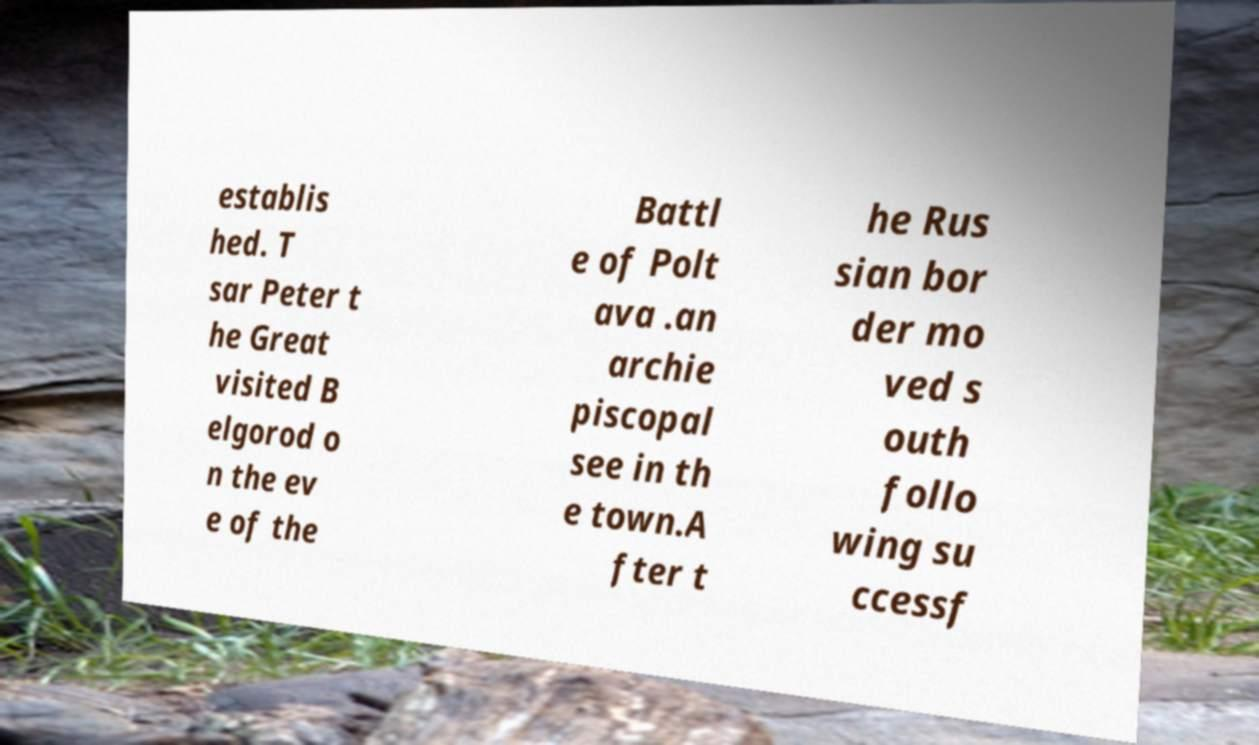What messages or text are displayed in this image? I need them in a readable, typed format. establis hed. T sar Peter t he Great visited B elgorod o n the ev e of the Battl e of Polt ava .an archie piscopal see in th e town.A fter t he Rus sian bor der mo ved s outh follo wing su ccessf 